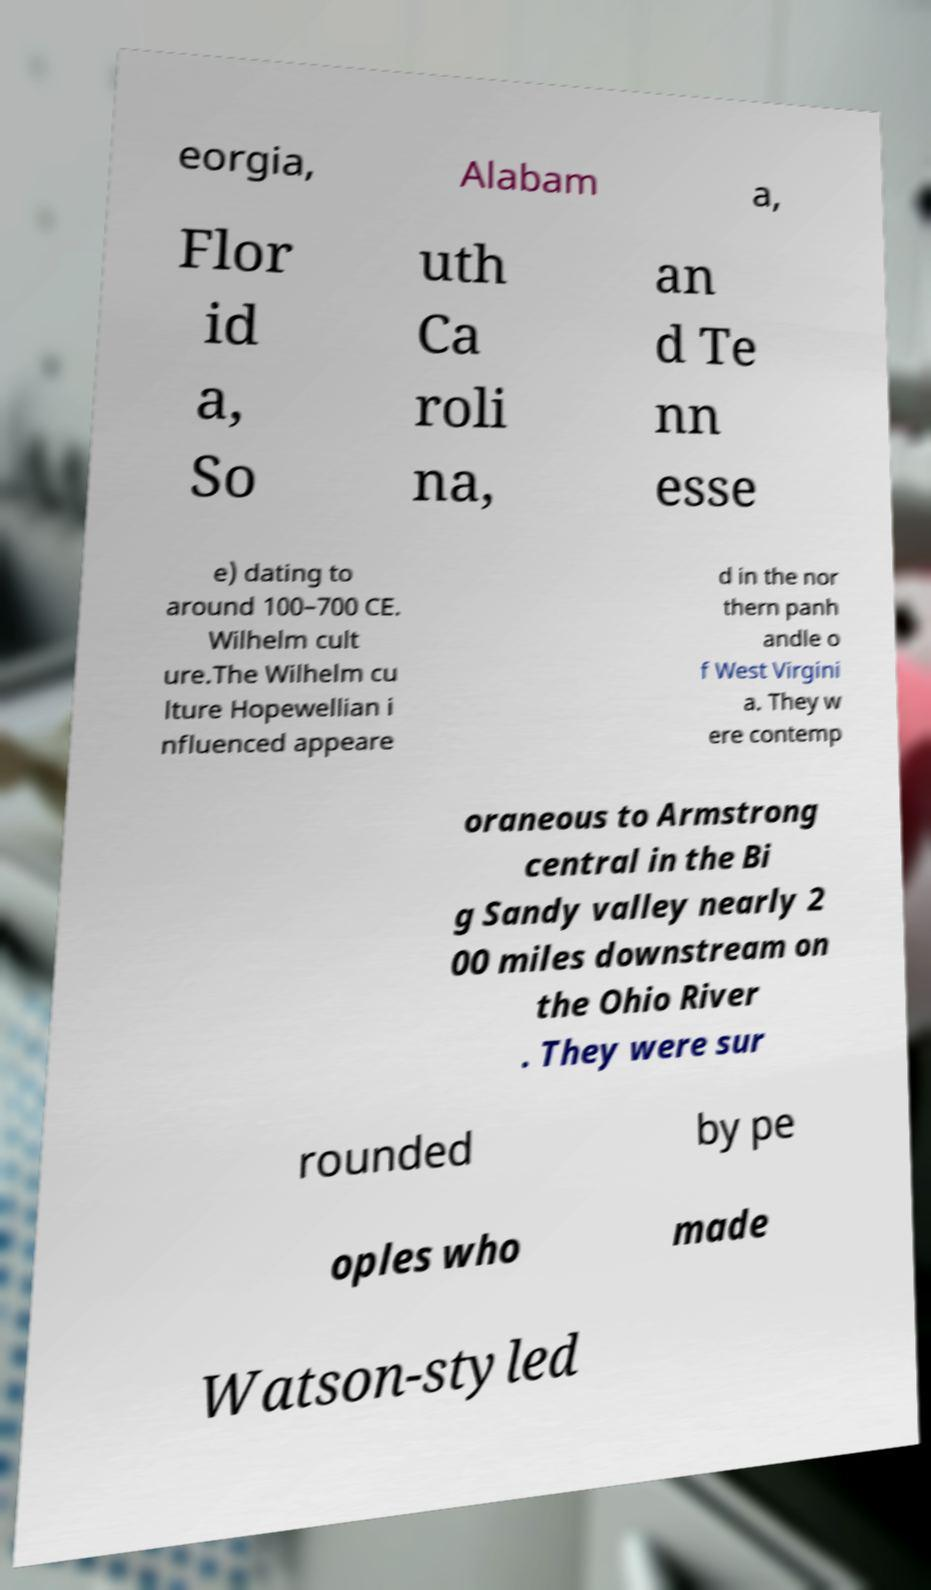For documentation purposes, I need the text within this image transcribed. Could you provide that? eorgia, Alabam a, Flor id a, So uth Ca roli na, an d Te nn esse e) dating to around 100–700 CE. Wilhelm cult ure.The Wilhelm cu lture Hopewellian i nfluenced appeare d in the nor thern panh andle o f West Virgini a. They w ere contemp oraneous to Armstrong central in the Bi g Sandy valley nearly 2 00 miles downstream on the Ohio River . They were sur rounded by pe oples who made Watson-styled 